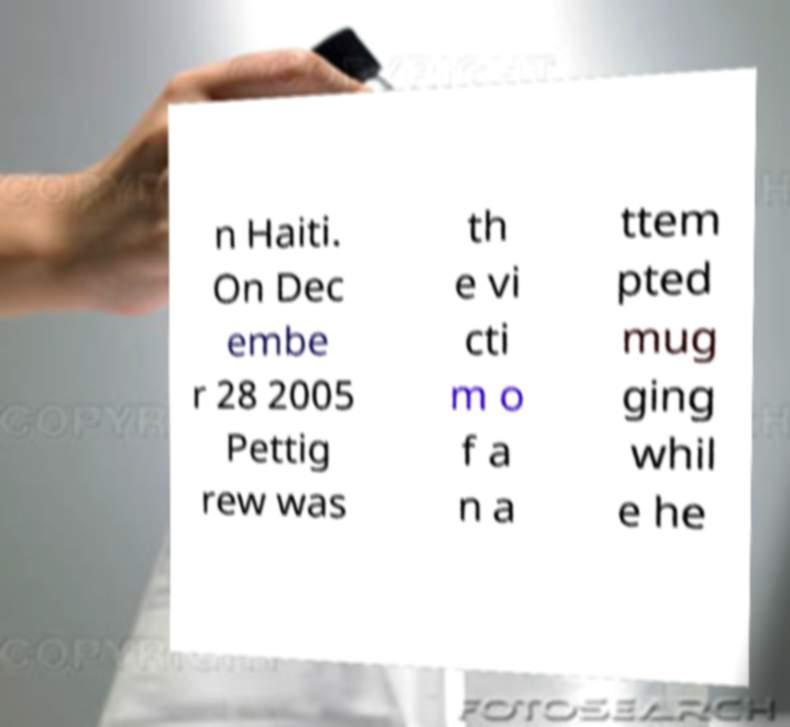For documentation purposes, I need the text within this image transcribed. Could you provide that? n Haiti. On Dec embe r 28 2005 Pettig rew was th e vi cti m o f a n a ttem pted mug ging whil e he 